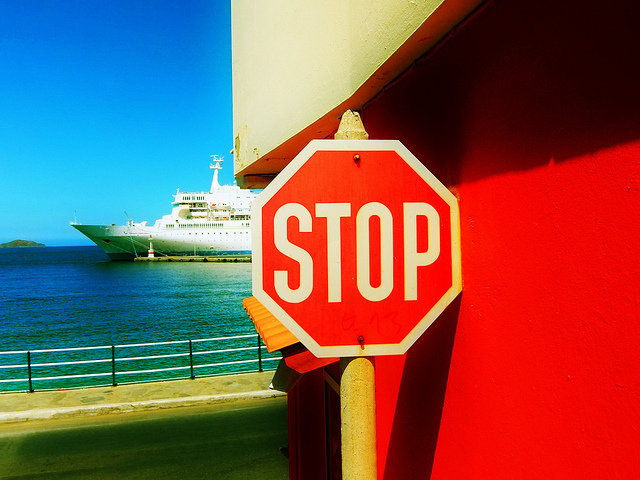Can you describe the body of water and the vessel in the background? Certainly, the image shows a calm body of water with a clear sky above it. In the background, there is a large, white vessel that looks like a passenger ship, signifying that this area could be close to a harbor or a dock primarily used for marine transport. 